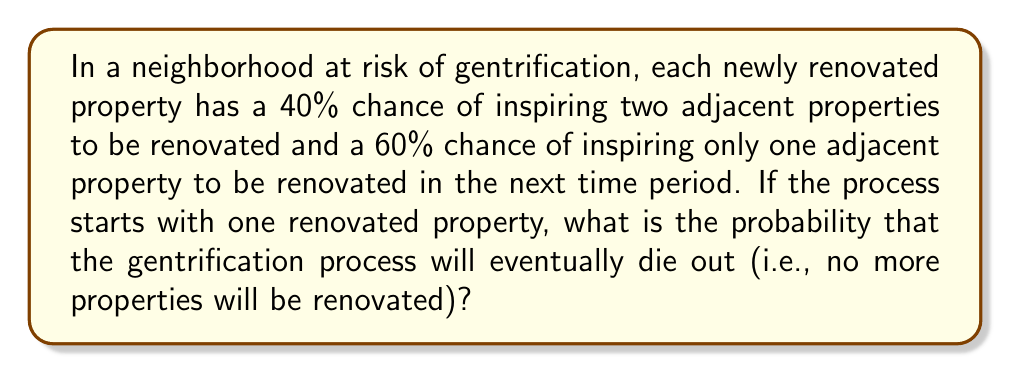Provide a solution to this math problem. To solve this problem, we can model the spread of gentrification as a branching process. Let's approach this step-by-step:

1) Let $p_0$, $p_1$, and $p_2$ be the probabilities of a property inspiring 0, 1, and 2 renovations respectively. From the given information:
   $p_0 = 0$
   $p_1 = 0.6$
   $p_2 = 0.4$

2) The probability generating function (PGF) for this process is:
   $$G(s) = p_0 + p_1s + p_2s^2 = 0.6s + 0.4s^2$$

3) For a branching process to die out, we need to find the smallest non-negative root of the equation $s = G(s)$ in the interval $[0,1]$.

4) Let's set up this equation:
   $$s = 0.6s + 0.4s^2$$

5) Rearranging the terms:
   $$0.4s^2 + 0.4s - 1 = 0$$

6) This is a quadratic equation. We can solve it using the quadratic formula:
   $$s = \frac{-b \pm \sqrt{b^2 - 4ac}}{2a}$$
   where $a = 0.4$, $b = 0.4$, and $c = -1$

7) Plugging in these values:
   $$s = \frac{-0.4 \pm \sqrt{0.4^2 - 4(0.4)(-1)}}{2(0.4)}$$
   $$= \frac{-0.4 \pm \sqrt{0.16 + 1.6}}{0.8}$$
   $$= \frac{-0.4 \pm \sqrt{1.76}}{0.8}$$
   $$= \frac{-0.4 \pm 1.327}{0.8}$$

8) This gives us two solutions:
   $s_1 = \frac{-0.4 + 1.327}{0.8} = 1.159$
   $s_2 = \frac{-0.4 - 1.327}{0.8} = -2.159$

9) Since we're looking for a probability, we need a value between 0 and 1. The only solution that fits this criterion is $s_2 = 1$.

10) However, $s = 1$ is always a trivial solution to $s = G(s)$ for any PGF. The fact that this is the only solution in $[0,1]$ means that the process will never die out with probability 1.

Therefore, the probability that the gentrification process will eventually die out is 0.
Answer: 0 